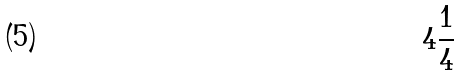<formula> <loc_0><loc_0><loc_500><loc_500>4 \frac { 1 } { 4 }</formula> 